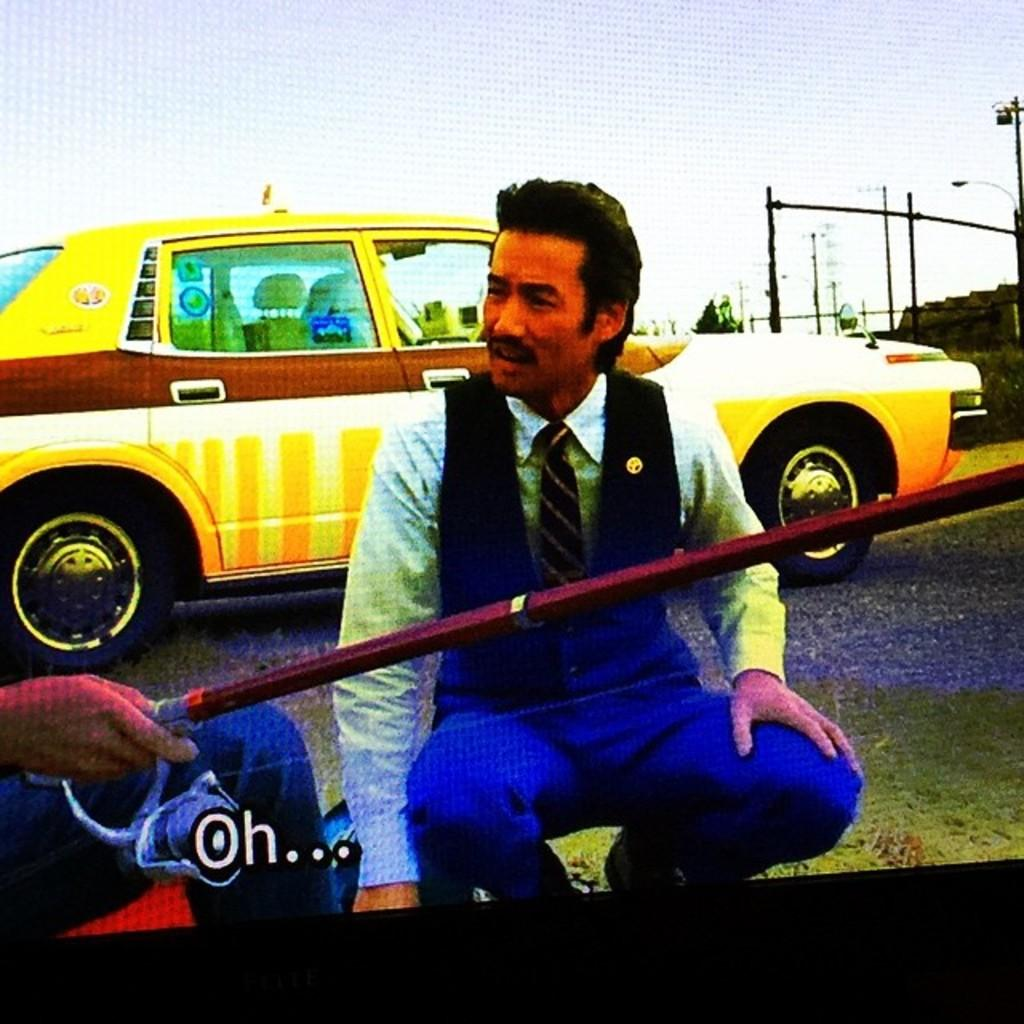<image>
Write a terse but informative summary of the picture. Gentleman sitting beside a man with a fishing rode telling him OH... 